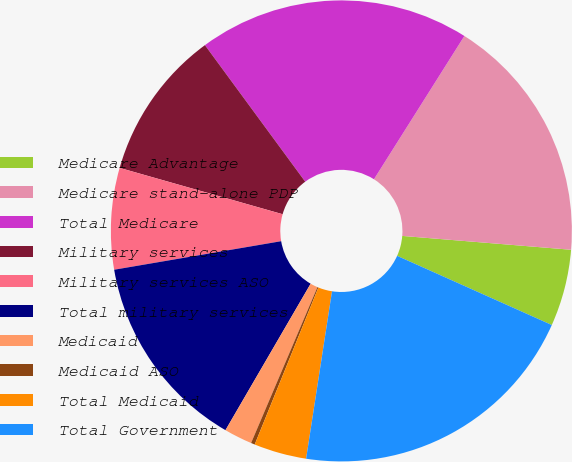Convert chart to OTSL. <chart><loc_0><loc_0><loc_500><loc_500><pie_chart><fcel>Medicare Advantage<fcel>Medicare stand-alone PDP<fcel>Total Medicare<fcel>Military services<fcel>Military services ASO<fcel>Total military services<fcel>Medicaid<fcel>Medicaid ASO<fcel>Total Medicaid<fcel>Total Government<nl><fcel>5.39%<fcel>17.34%<fcel>19.04%<fcel>10.51%<fcel>7.1%<fcel>13.92%<fcel>1.98%<fcel>0.27%<fcel>3.69%<fcel>20.75%<nl></chart> 